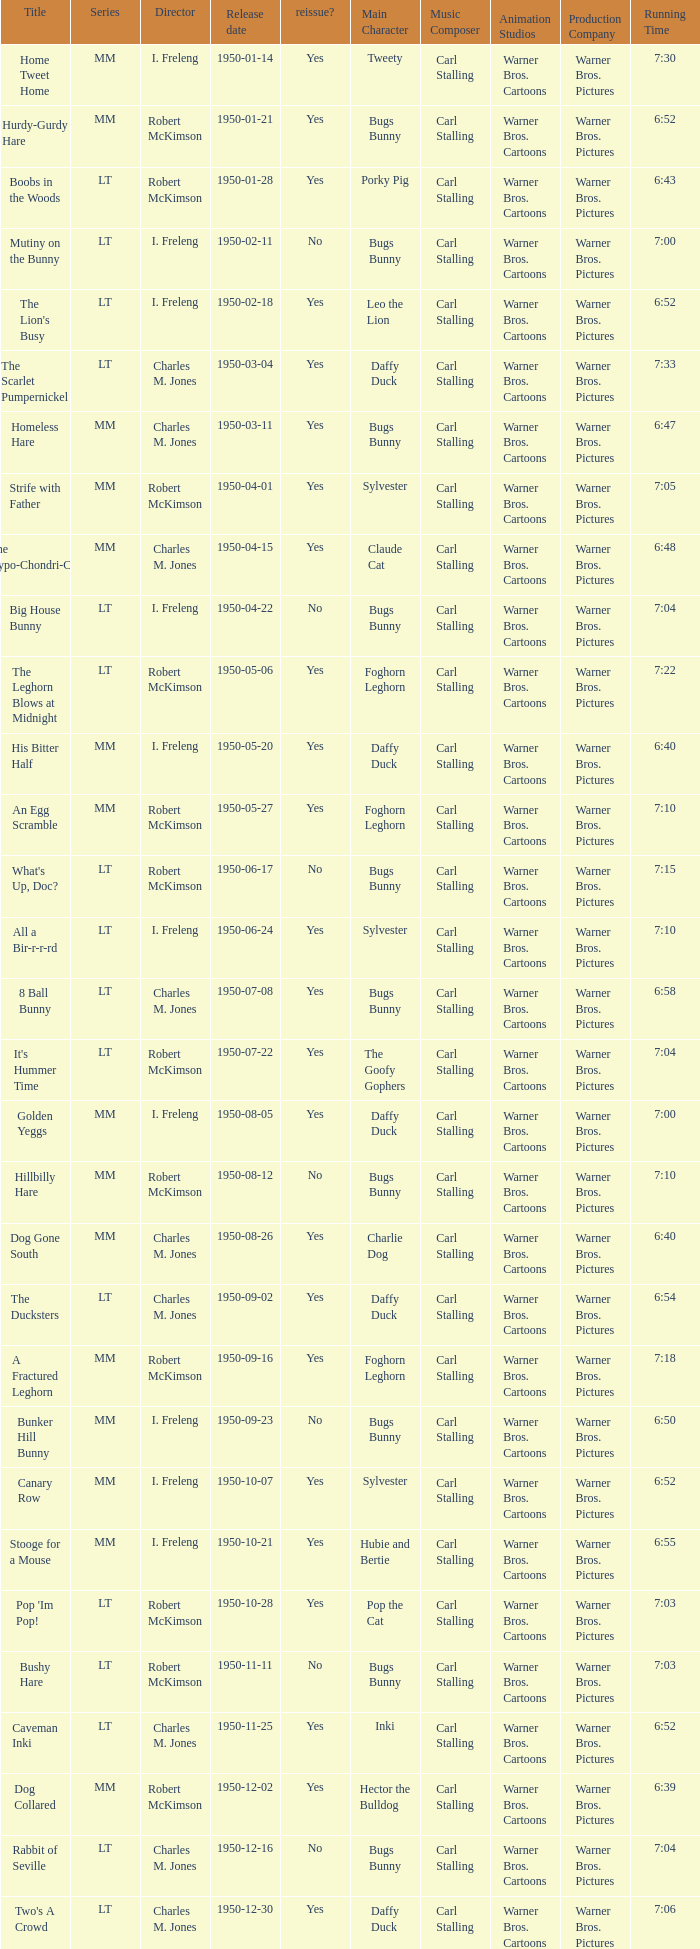Who directed An Egg Scramble? Robert McKimson. 